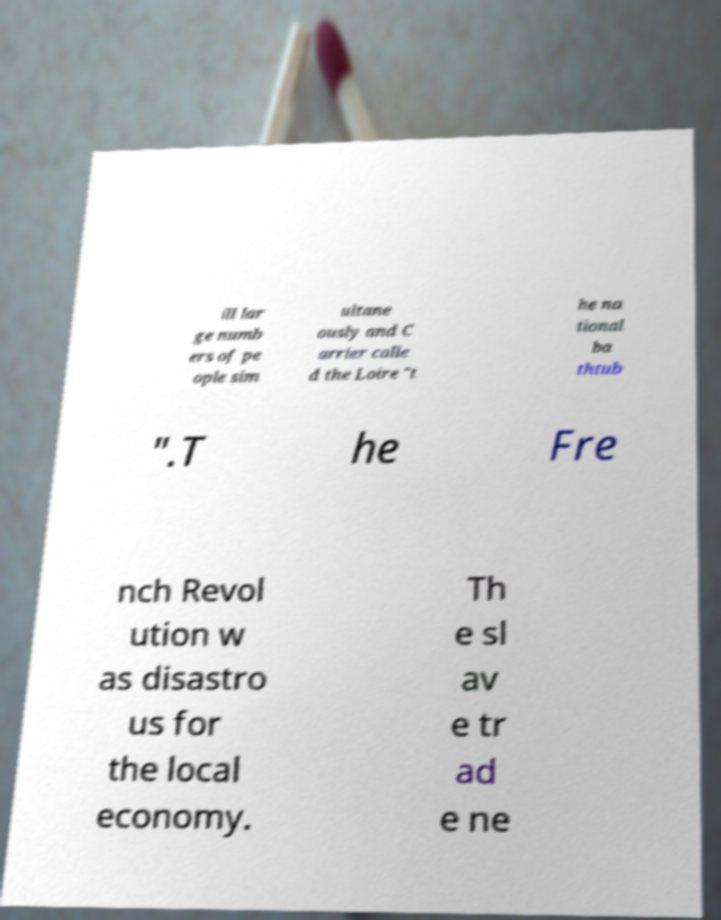I need the written content from this picture converted into text. Can you do that? ill lar ge numb ers of pe ople sim ultane ously and C arrier calle d the Loire "t he na tional ba thtub ".T he Fre nch Revol ution w as disastro us for the local economy. Th e sl av e tr ad e ne 